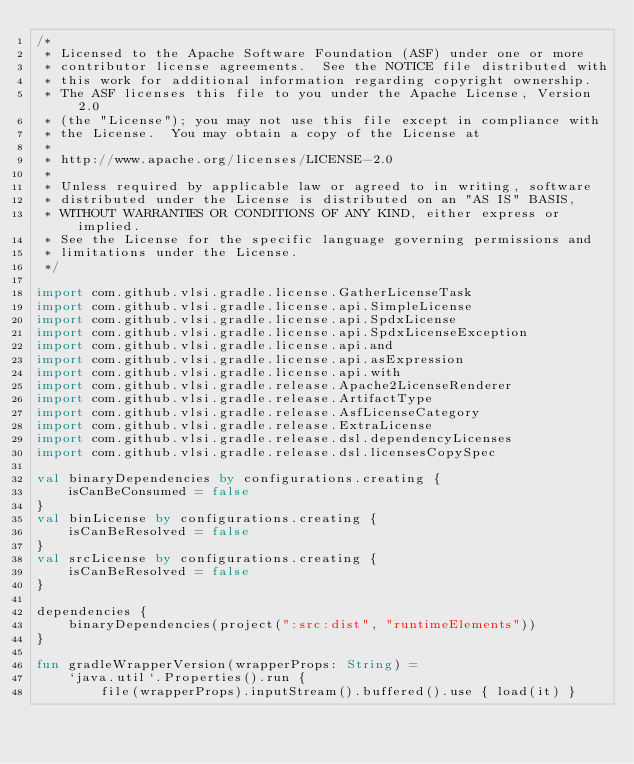<code> <loc_0><loc_0><loc_500><loc_500><_Kotlin_>/*
 * Licensed to the Apache Software Foundation (ASF) under one or more
 * contributor license agreements.  See the NOTICE file distributed with
 * this work for additional information regarding copyright ownership.
 * The ASF licenses this file to you under the Apache License, Version 2.0
 * (the "License"); you may not use this file except in compliance with
 * the License.  You may obtain a copy of the License at
 *
 * http://www.apache.org/licenses/LICENSE-2.0
 *
 * Unless required by applicable law or agreed to in writing, software
 * distributed under the License is distributed on an "AS IS" BASIS,
 * WITHOUT WARRANTIES OR CONDITIONS OF ANY KIND, either express or implied.
 * See the License for the specific language governing permissions and
 * limitations under the License.
 */

import com.github.vlsi.gradle.license.GatherLicenseTask
import com.github.vlsi.gradle.license.api.SimpleLicense
import com.github.vlsi.gradle.license.api.SpdxLicense
import com.github.vlsi.gradle.license.api.SpdxLicenseException
import com.github.vlsi.gradle.license.api.and
import com.github.vlsi.gradle.license.api.asExpression
import com.github.vlsi.gradle.license.api.with
import com.github.vlsi.gradle.release.Apache2LicenseRenderer
import com.github.vlsi.gradle.release.ArtifactType
import com.github.vlsi.gradle.release.AsfLicenseCategory
import com.github.vlsi.gradle.release.ExtraLicense
import com.github.vlsi.gradle.release.dsl.dependencyLicenses
import com.github.vlsi.gradle.release.dsl.licensesCopySpec

val binaryDependencies by configurations.creating {
    isCanBeConsumed = false
}
val binLicense by configurations.creating {
    isCanBeResolved = false
}
val srcLicense by configurations.creating {
    isCanBeResolved = false
}

dependencies {
    binaryDependencies(project(":src:dist", "runtimeElements"))
}

fun gradleWrapperVersion(wrapperProps: String) =
    `java.util`.Properties().run {
        file(wrapperProps).inputStream().buffered().use { load(it) }</code> 